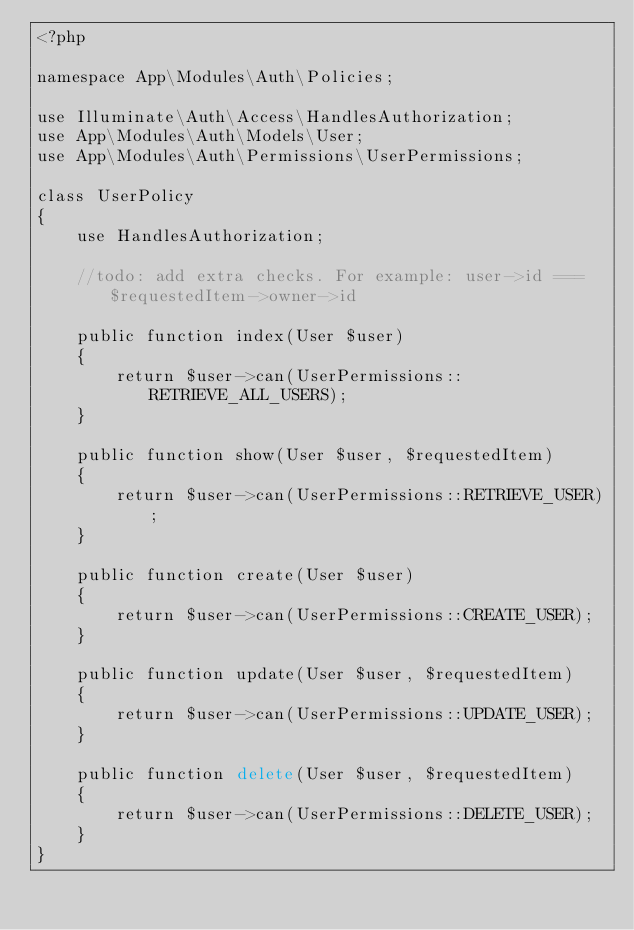Convert code to text. <code><loc_0><loc_0><loc_500><loc_500><_PHP_><?php

namespace App\Modules\Auth\Policies;

use Illuminate\Auth\Access\HandlesAuthorization;
use App\Modules\Auth\Models\User;
use App\Modules\Auth\Permissions\UserPermissions;

class UserPolicy
{
    use HandlesAuthorization;

    //todo: add extra checks. For example: user->id === $requestedItem->owner->id

    public function index(User $user)
    {
        return $user->can(UserPermissions::RETRIEVE_ALL_USERS);
    }

    public function show(User $user, $requestedItem)
    {
        return $user->can(UserPermissions::RETRIEVE_USER);
    }

    public function create(User $user)
    {
        return $user->can(UserPermissions::CREATE_USER);
    }

    public function update(User $user, $requestedItem)
    {
        return $user->can(UserPermissions::UPDATE_USER);
    }

    public function delete(User $user, $requestedItem)
    {
        return $user->can(UserPermissions::DELETE_USER);
    }
}
</code> 